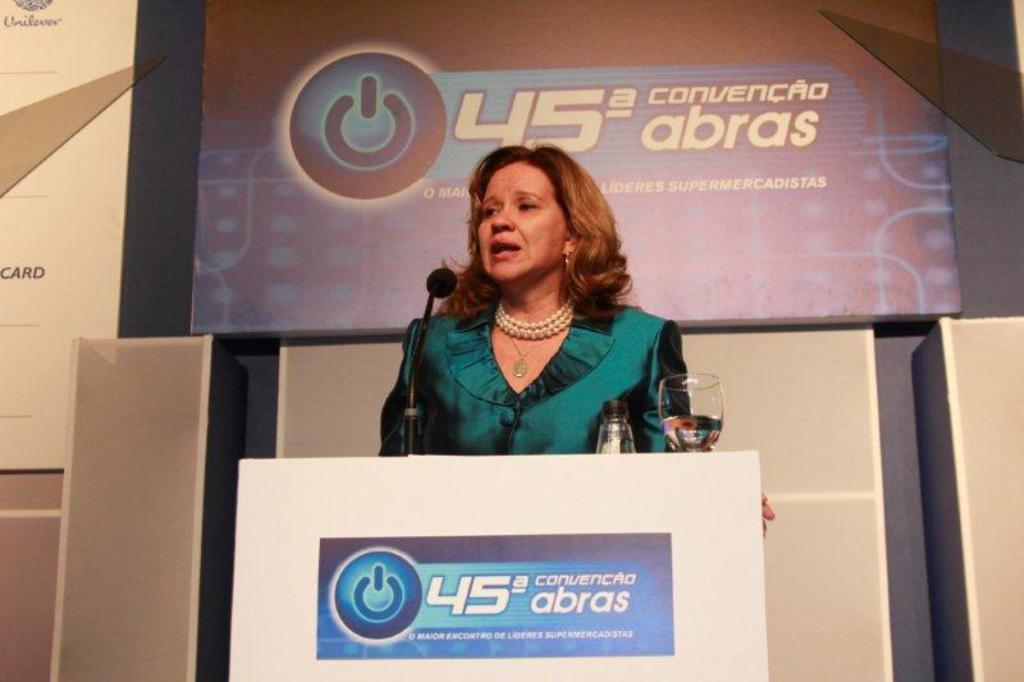In one or two sentences, can you explain what this image depicts? In this image I can see a woman standing in front of a podium. In the background I can see a board with some text on it. 